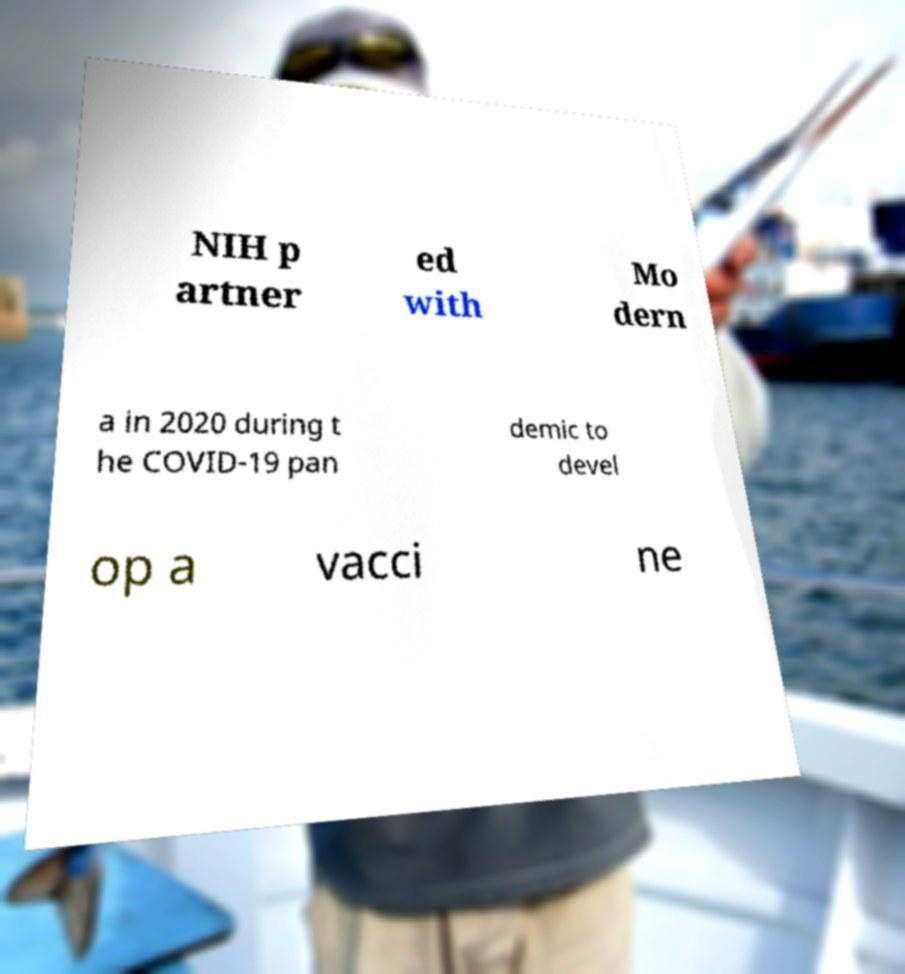Could you assist in decoding the text presented in this image and type it out clearly? NIH p artner ed with Mo dern a in 2020 during t he COVID-19 pan demic to devel op a vacci ne 